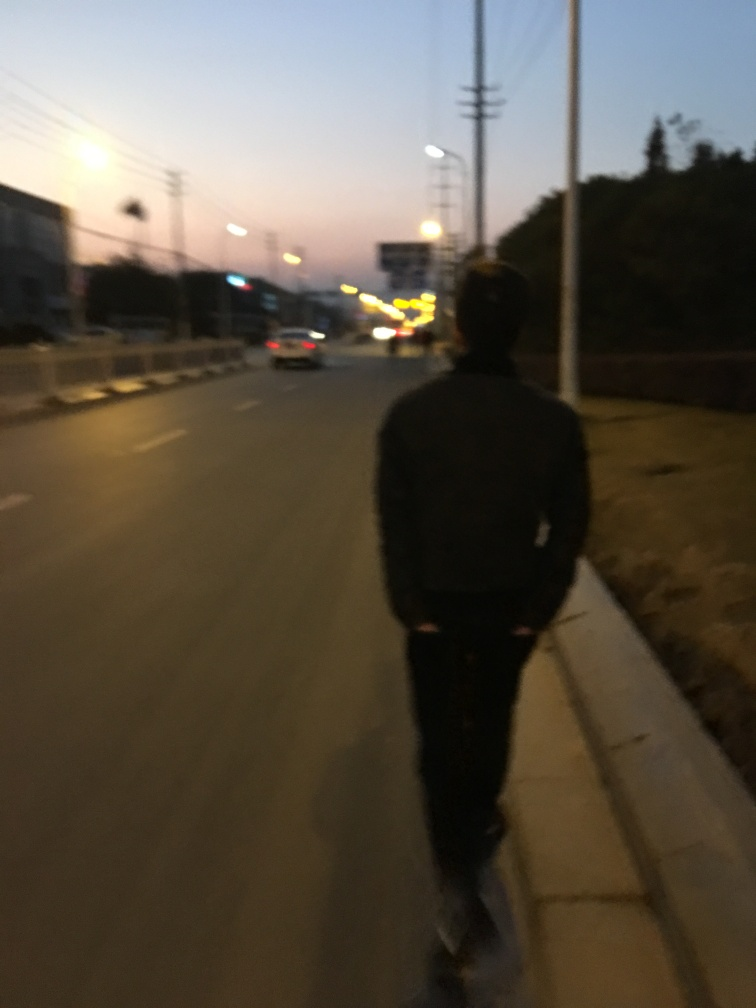Is the background clear or blurry? Upon reviewing the image, we can see that the background lacks sharpness and details which are not distinctly visible, indicating a blurry background often caused by motion or low light conditions. 